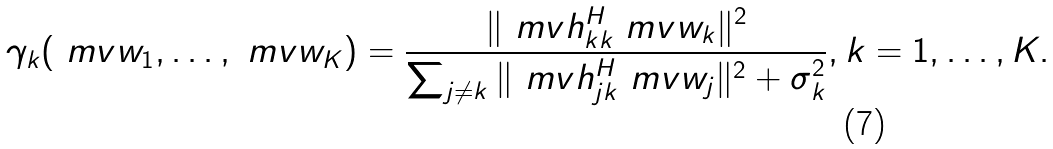Convert formula to latex. <formula><loc_0><loc_0><loc_500><loc_500>\gamma _ { k } ( \ m v { w } _ { 1 } , \dots , \ m v { w } _ { K } ) = \frac { \| \ m v { h } _ { k k } ^ { H } \ m v { w } _ { k } \| ^ { 2 } } { \sum _ { j \neq k } \| \ m v { h } _ { j k } ^ { H } \ m v { w } _ { j } \| ^ { 2 } + \sigma _ { k } ^ { 2 } } , k = 1 , \dots , K .</formula> 